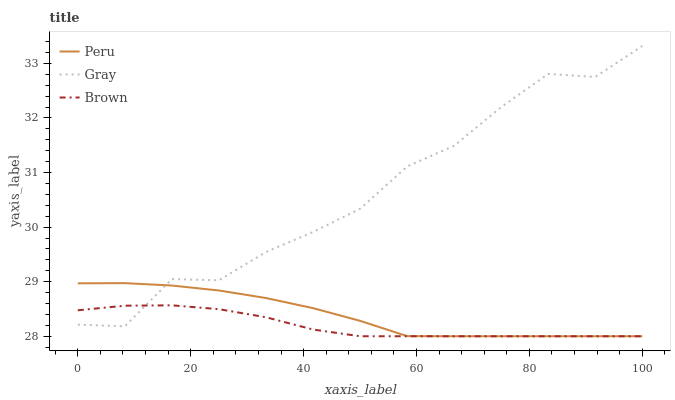Does Peru have the minimum area under the curve?
Answer yes or no. No. Does Peru have the maximum area under the curve?
Answer yes or no. No. Is Peru the smoothest?
Answer yes or no. No. Is Peru the roughest?
Answer yes or no. No. Does Peru have the highest value?
Answer yes or no. No. 